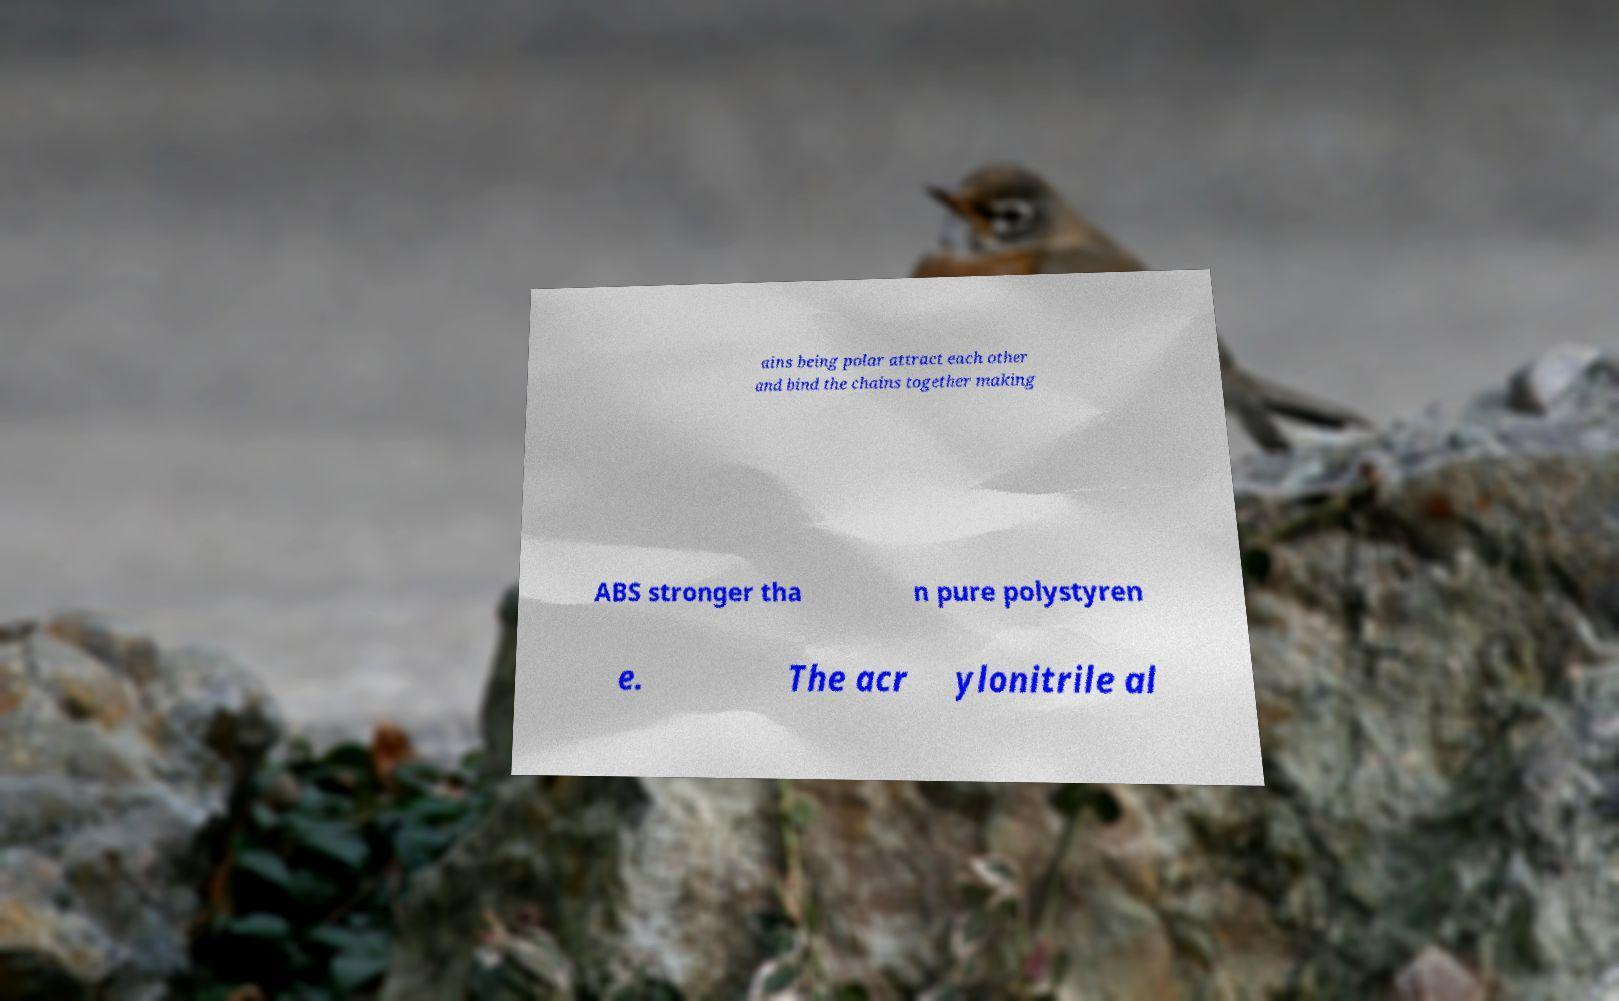Can you read and provide the text displayed in the image?This photo seems to have some interesting text. Can you extract and type it out for me? ains being polar attract each other and bind the chains together making ABS stronger tha n pure polystyren e. The acr ylonitrile al 